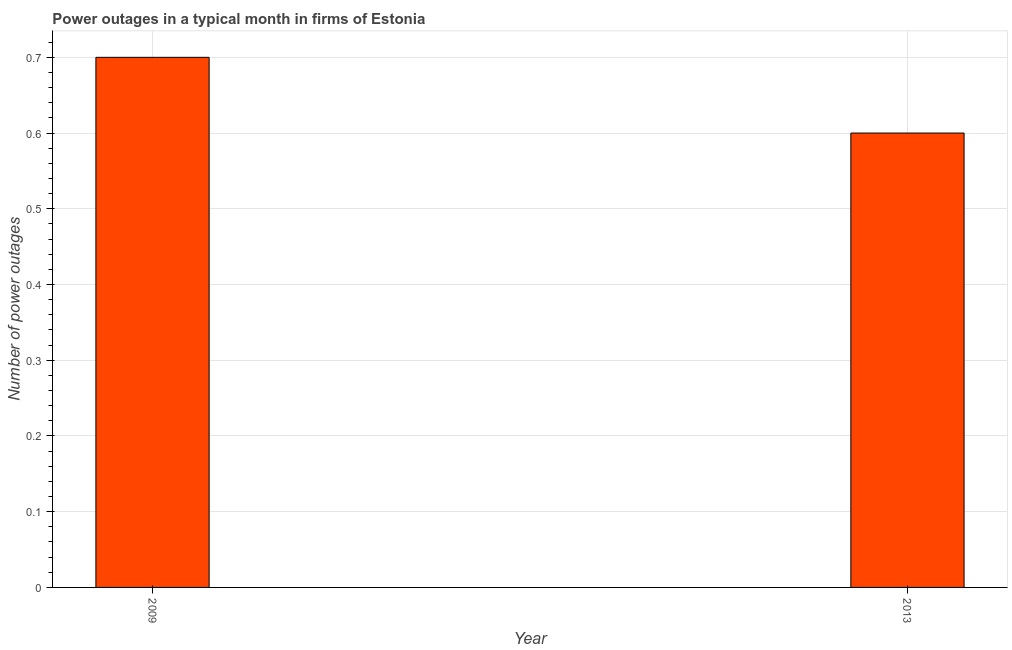Does the graph contain any zero values?
Offer a terse response. No. Does the graph contain grids?
Make the answer very short. Yes. What is the title of the graph?
Give a very brief answer. Power outages in a typical month in firms of Estonia. What is the label or title of the X-axis?
Your answer should be compact. Year. What is the label or title of the Y-axis?
Your answer should be compact. Number of power outages. What is the number of power outages in 2013?
Offer a terse response. 0.6. Across all years, what is the maximum number of power outages?
Your answer should be compact. 0.7. In which year was the number of power outages maximum?
Ensure brevity in your answer.  2009. What is the sum of the number of power outages?
Provide a short and direct response. 1.3. What is the difference between the number of power outages in 2009 and 2013?
Offer a terse response. 0.1. What is the average number of power outages per year?
Your response must be concise. 0.65. What is the median number of power outages?
Provide a short and direct response. 0.65. What is the ratio of the number of power outages in 2009 to that in 2013?
Offer a terse response. 1.17. In how many years, is the number of power outages greater than the average number of power outages taken over all years?
Keep it short and to the point. 1. How many years are there in the graph?
Your answer should be compact. 2. What is the Number of power outages in 2009?
Provide a succinct answer. 0.7. What is the difference between the Number of power outages in 2009 and 2013?
Make the answer very short. 0.1. What is the ratio of the Number of power outages in 2009 to that in 2013?
Provide a short and direct response. 1.17. 